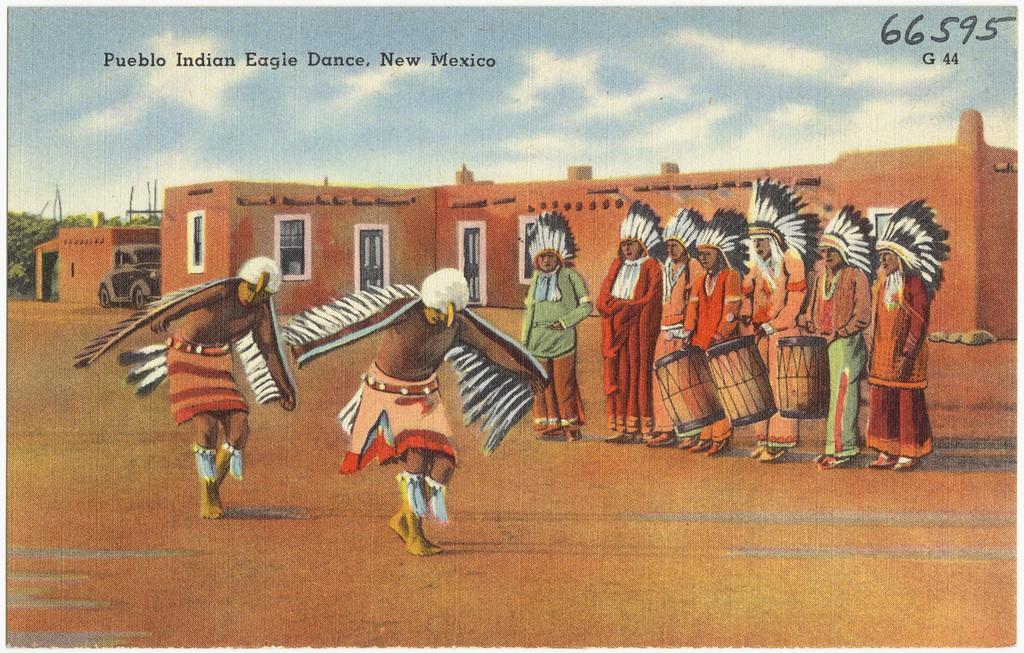Could you give a brief overview of what you see in this image? It is a painting, on the left side 2 men are performing different action on the right side. A group of persons are beating the drums and observing them, behind them there is the house. At the top it is the sky. 